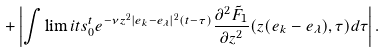Convert formula to latex. <formula><loc_0><loc_0><loc_500><loc_500>+ \left | \int \lim i t s _ { 0 } ^ { t } e ^ { - \nu z ^ { 2 } | e _ { k } - e _ { \lambda } | ^ { 2 } ( t - \tau ) } \frac { \partial ^ { 2 } { \tilde { F } _ { 1 } } } { \partial { z ^ { 2 } } } ( z ( e _ { k } - e _ { \lambda } ) , \tau ) d \tau \right | .</formula> 